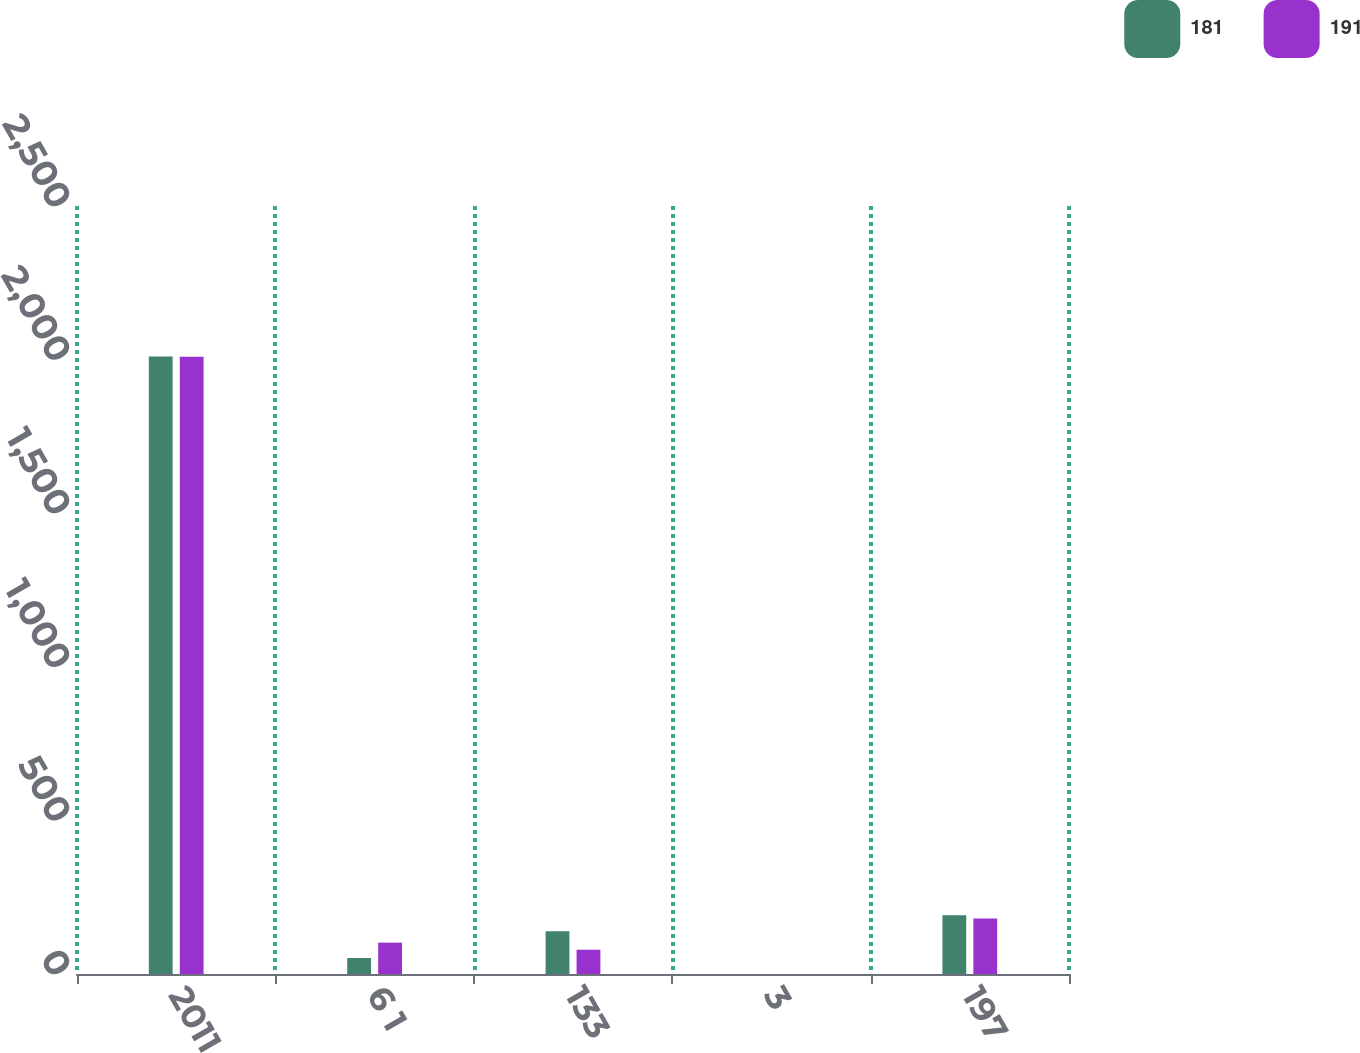<chart> <loc_0><loc_0><loc_500><loc_500><stacked_bar_chart><ecel><fcel>2011<fcel>6 1<fcel>133<fcel>3<fcel>197<nl><fcel>181<fcel>2010<fcel>52<fcel>139<fcel>0<fcel>191<nl><fcel>191<fcel>2009<fcel>102<fcel>79<fcel>0<fcel>181<nl></chart> 